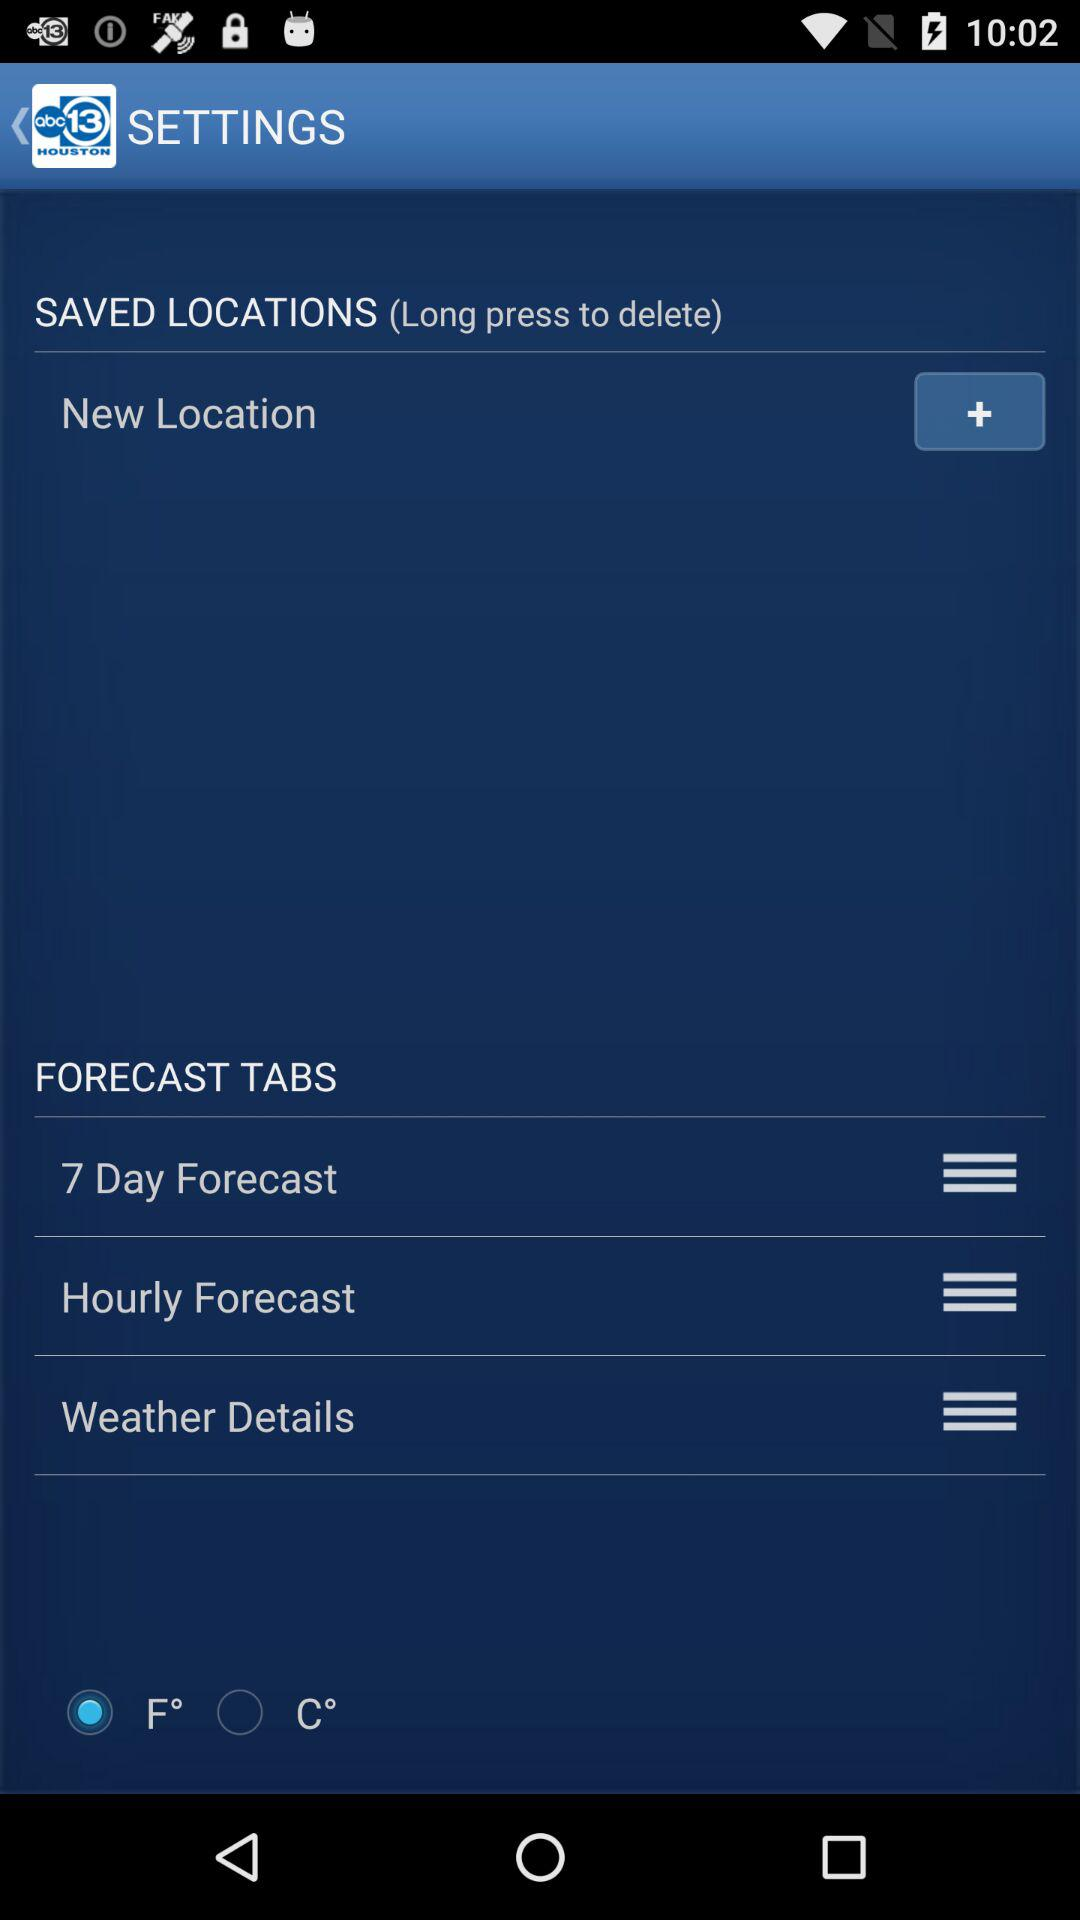Which option is selected? The selected option is "F°". 